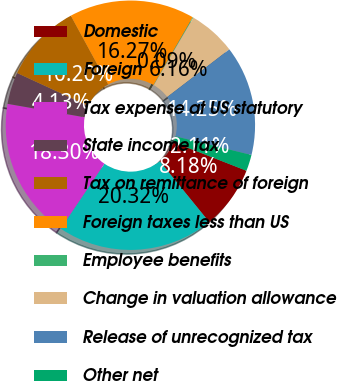<chart> <loc_0><loc_0><loc_500><loc_500><pie_chart><fcel>Domestic<fcel>Foreign<fcel>Tax expense at US statutory<fcel>State income tax<fcel>Tax on remittance of foreign<fcel>Foreign taxes less than US<fcel>Employee benefits<fcel>Change in valuation allowance<fcel>Release of unrecognized tax<fcel>Other net<nl><fcel>8.18%<fcel>20.32%<fcel>18.3%<fcel>4.13%<fcel>10.2%<fcel>16.27%<fcel>0.09%<fcel>6.16%<fcel>14.25%<fcel>2.11%<nl></chart> 